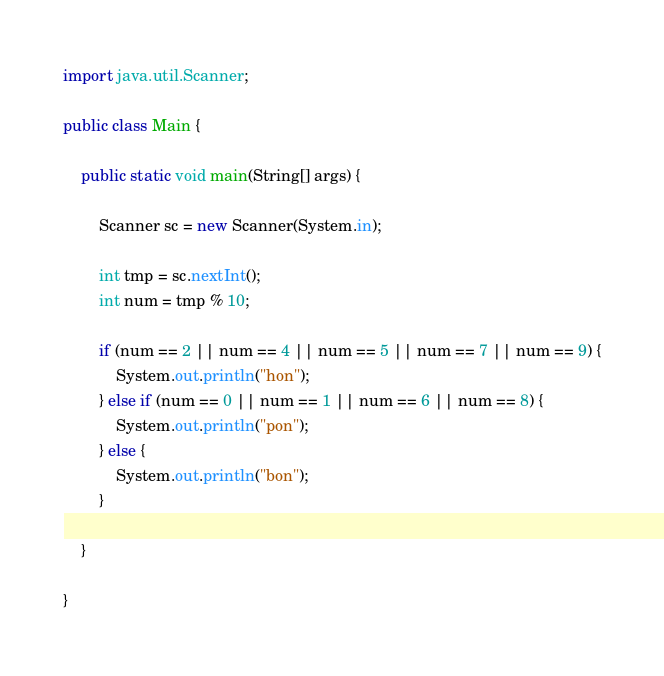<code> <loc_0><loc_0><loc_500><loc_500><_Java_>import java.util.Scanner;
 
public class Main {
 
	public static void main(String[] args) {
 
		Scanner sc = new Scanner(System.in);
 
		int tmp = sc.nextInt();
		int num = tmp % 10;
 
        if (num == 2 || num == 4 || num == 5 || num == 7 || num == 9) {
			System.out.println("hon");
		} else if (num == 0 || num == 1 || num == 6 || num == 8) {
			System.out.println("pon");
		} else {
			System.out.println("bon");
		}
 
	}
 
}</code> 